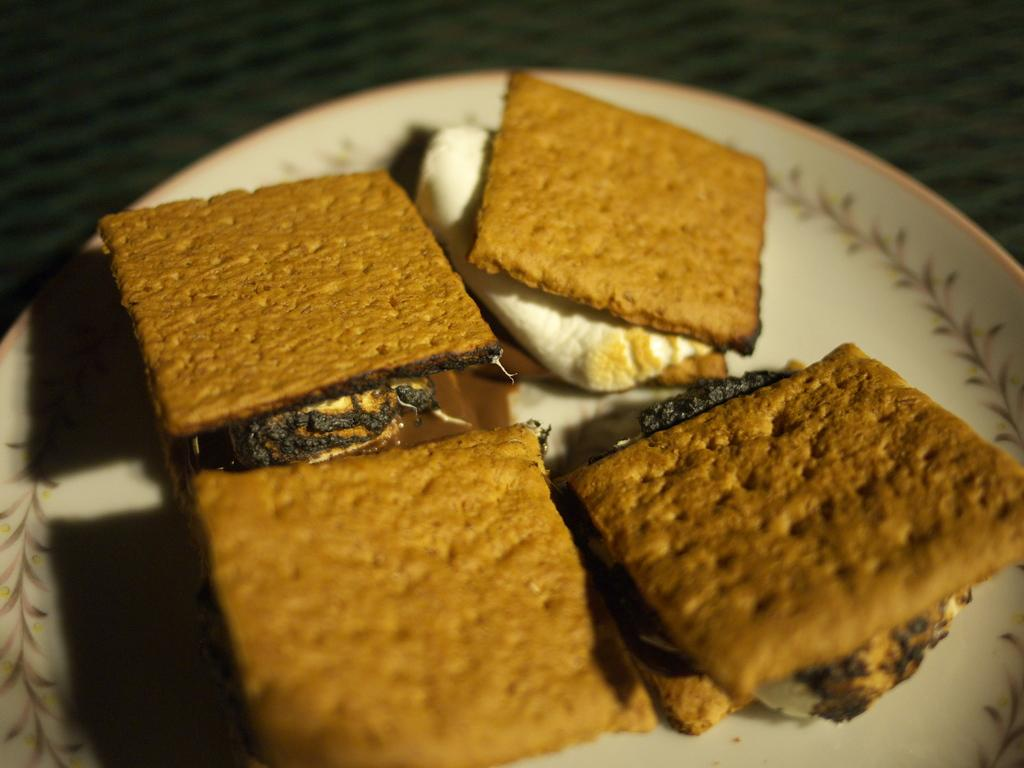What type of furniture is present in the image? There is a table in the image. What is placed on the table? There is a white color plate on the table. What is on the plate? There are biscuits on the plate. What type of trade is being conducted on the table in the image? There is no trade being conducted in the image; it simply shows a table with a plate of biscuits. 